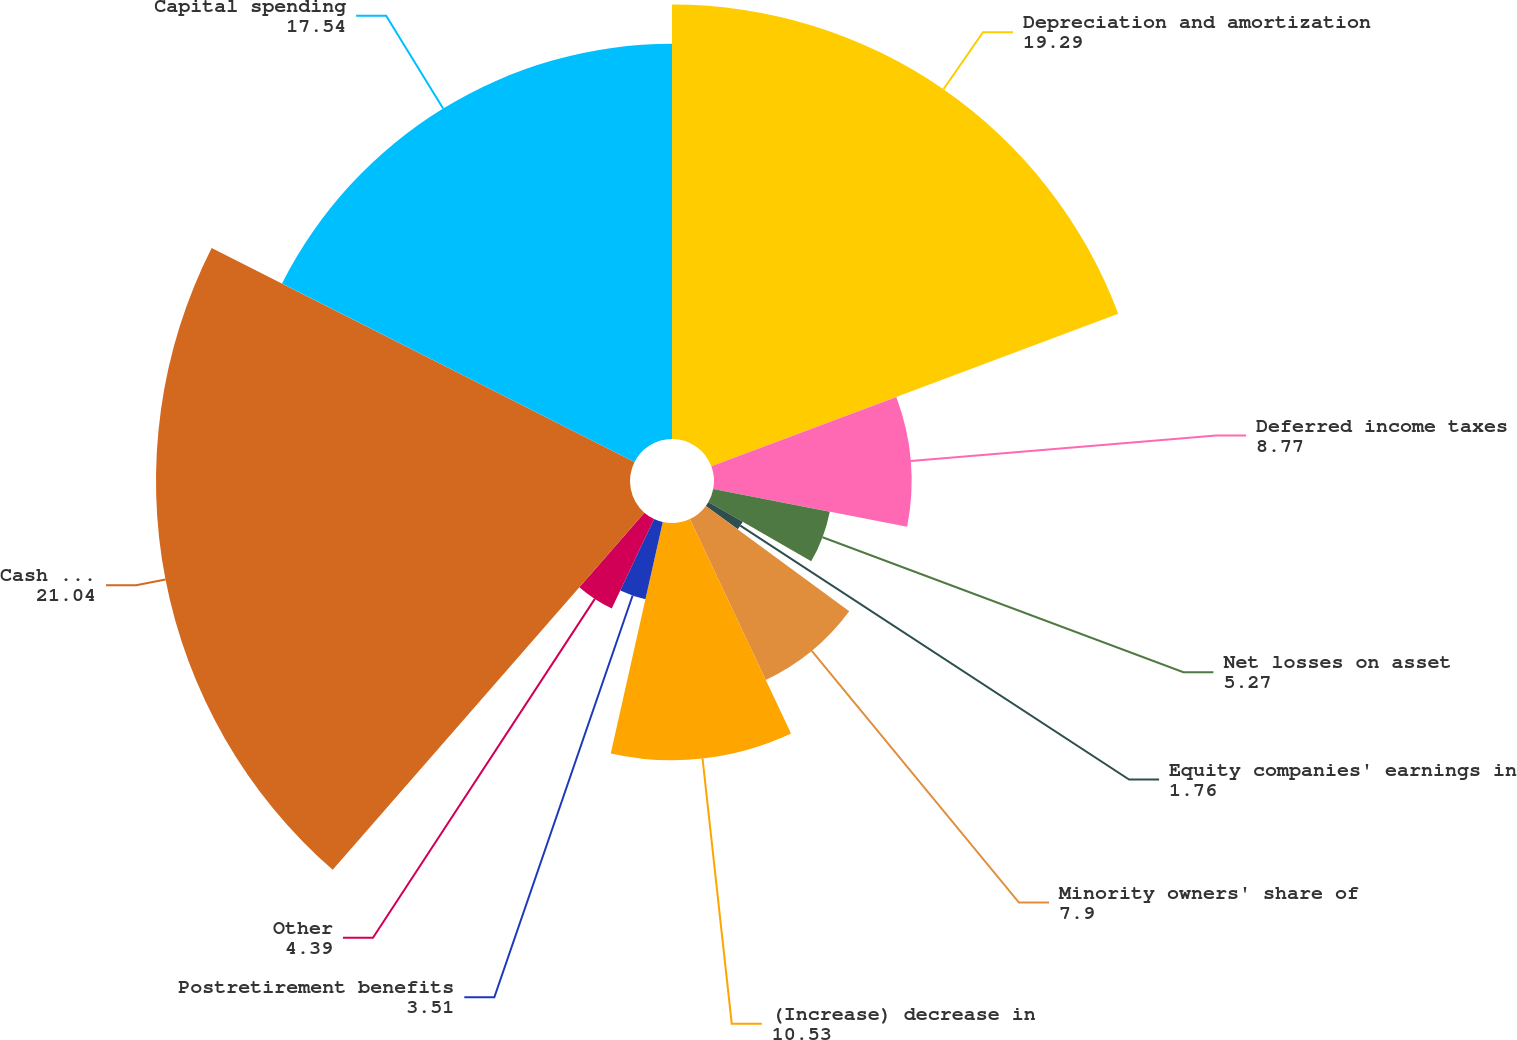Convert chart to OTSL. <chart><loc_0><loc_0><loc_500><loc_500><pie_chart><fcel>Depreciation and amortization<fcel>Deferred income taxes<fcel>Net losses on asset<fcel>Equity companies' earnings in<fcel>Minority owners' share of<fcel>(Increase) decrease in<fcel>Postretirement benefits<fcel>Other<fcel>Cash Provided by Operations<fcel>Capital spending<nl><fcel>19.29%<fcel>8.77%<fcel>5.27%<fcel>1.76%<fcel>7.9%<fcel>10.53%<fcel>3.51%<fcel>4.39%<fcel>21.04%<fcel>17.54%<nl></chart> 